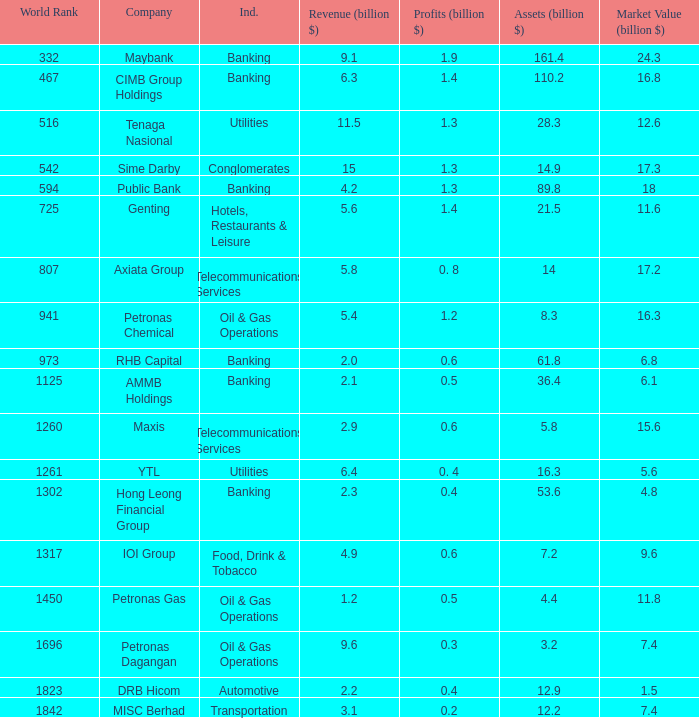Name the world rank for market value 17.2 807.0. 